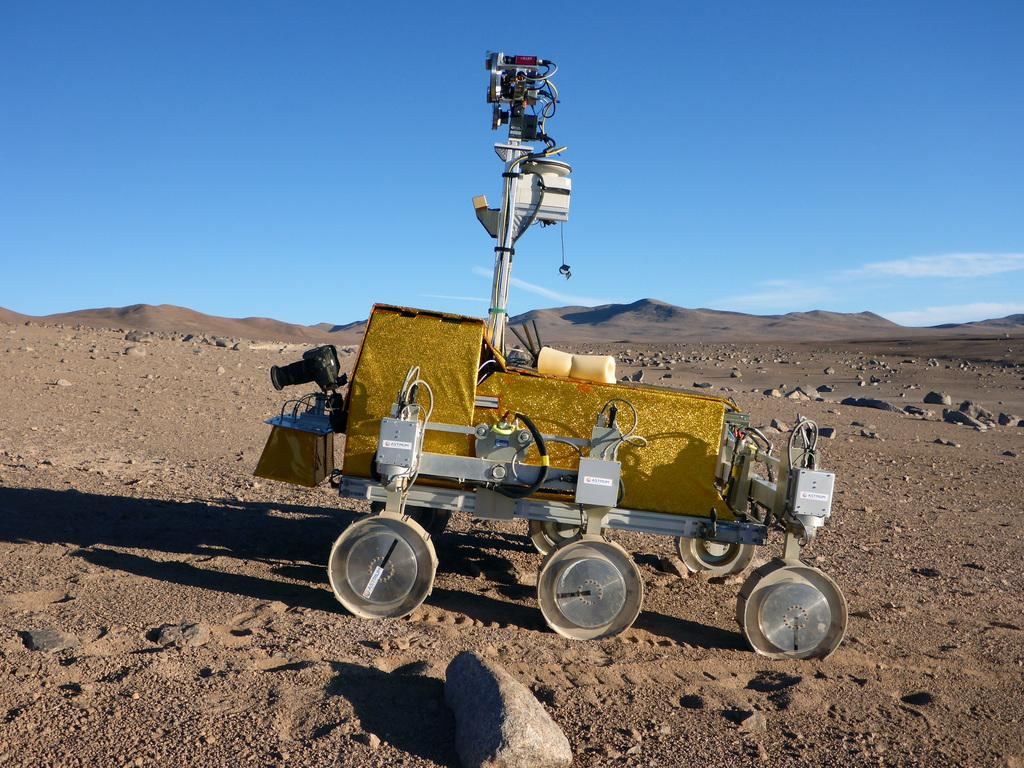What type of vehicle is in the image? There is a machine vehicle in the image. What is the machine vehicle doing in the image? The machine vehicle is moving on the ground. What type of terrain can be seen in the image? There are stones visible in the image. What can be seen in the distance in the image? There are hills in the background of the image. How would you describe the sky in the image? The sky is blue with clouds in the background. How much money is the ant carrying on the horse in the image? There is no ant, money, or horse present in the image. 